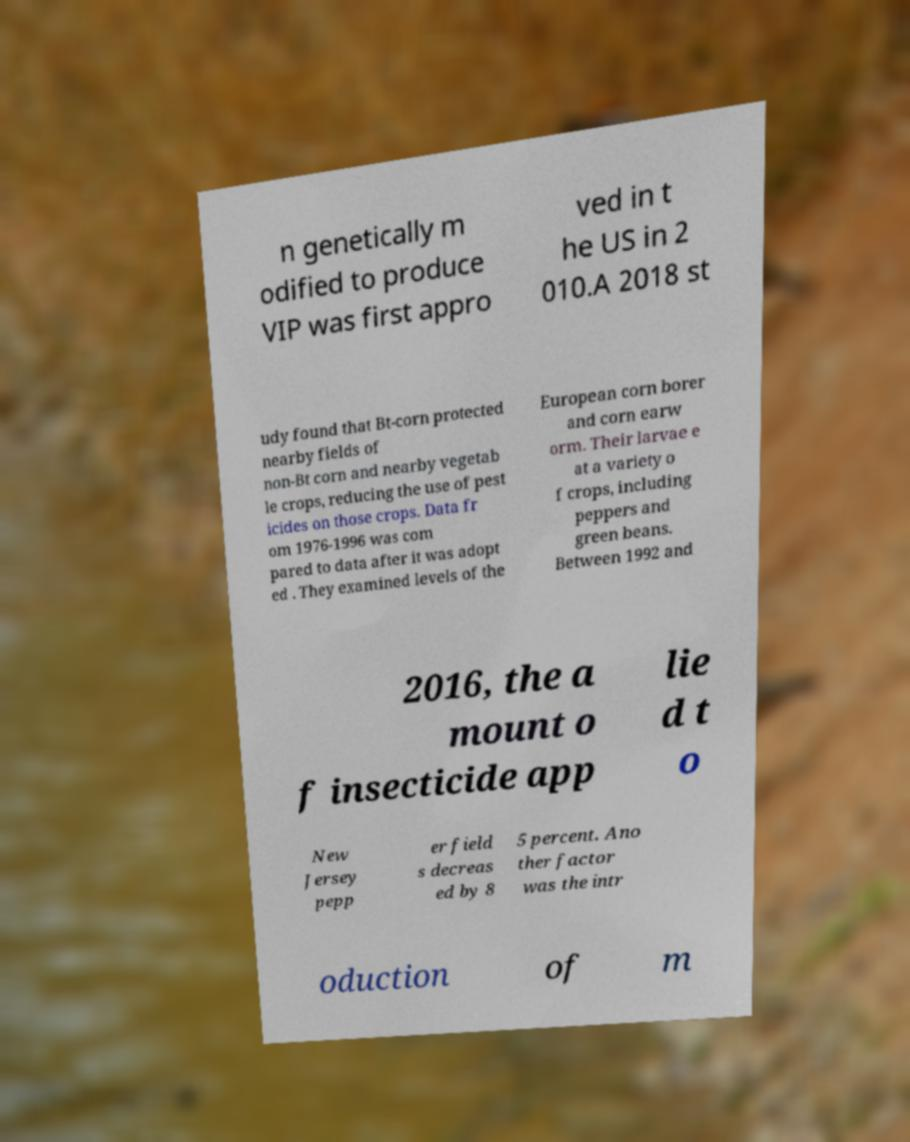There's text embedded in this image that I need extracted. Can you transcribe it verbatim? n genetically m odified to produce VIP was first appro ved in t he US in 2 010.A 2018 st udy found that Bt-corn protected nearby fields of non-Bt corn and nearby vegetab le crops, reducing the use of pest icides on those crops. Data fr om 1976-1996 was com pared to data after it was adopt ed . They examined levels of the European corn borer and corn earw orm. Their larvae e at a variety o f crops, including peppers and green beans. Between 1992 and 2016, the a mount o f insecticide app lie d t o New Jersey pepp er field s decreas ed by 8 5 percent. Ano ther factor was the intr oduction of m 